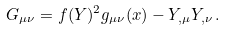<formula> <loc_0><loc_0><loc_500><loc_500>G _ { \mu \nu } = f ( Y ) ^ { 2 } g _ { \mu \nu } ( x ) - Y _ { , \mu } Y _ { , \nu } \, .</formula> 